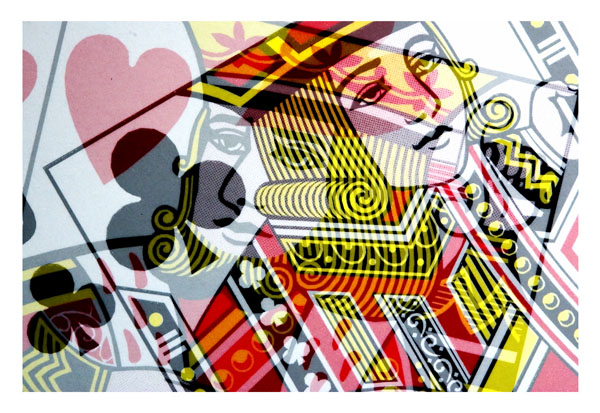What is the main subject of the image?
A. a car
B. a cat
C. playing cards
D. a dog
Answer with the option's letter from the given choices directly.
 D. 